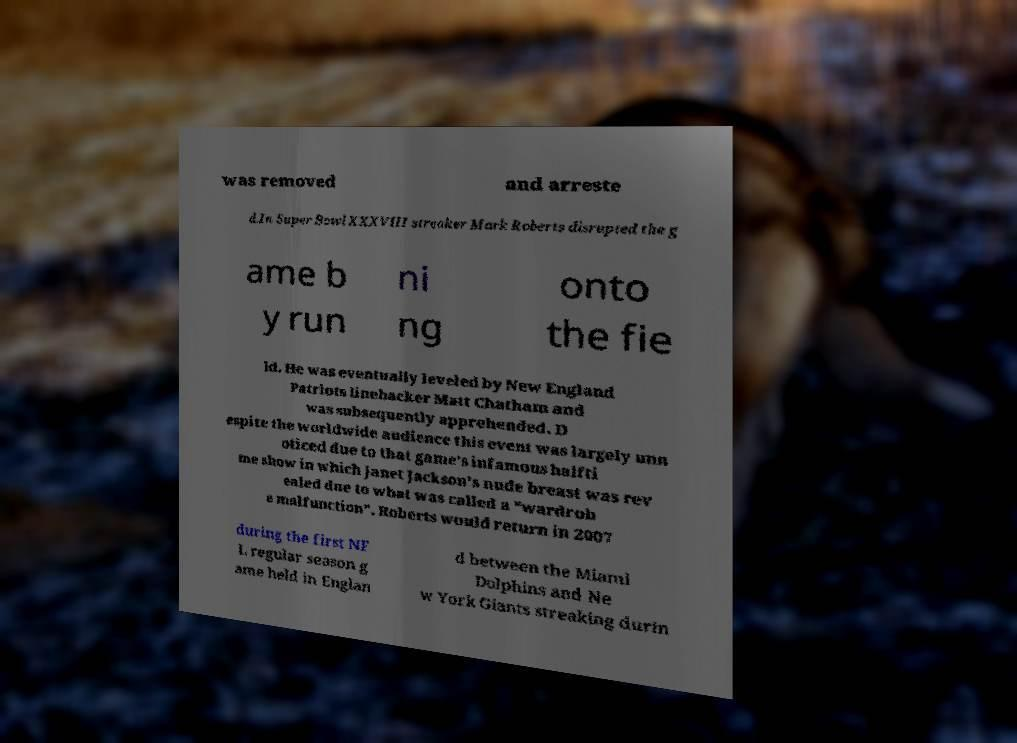What messages or text are displayed in this image? I need them in a readable, typed format. was removed and arreste d.In Super Bowl XXXVIII streaker Mark Roberts disrupted the g ame b y run ni ng onto the fie ld. He was eventually leveled by New England Patriots linebacker Matt Chatham and was subsequently apprehended. D espite the worldwide audience this event was largely unn oticed due to that game's infamous halfti me show in which Janet Jackson's nude breast was rev ealed due to what was called a "wardrob e malfunction". Roberts would return in 2007 during the first NF L regular season g ame held in Englan d between the Miami Dolphins and Ne w York Giants streaking durin 